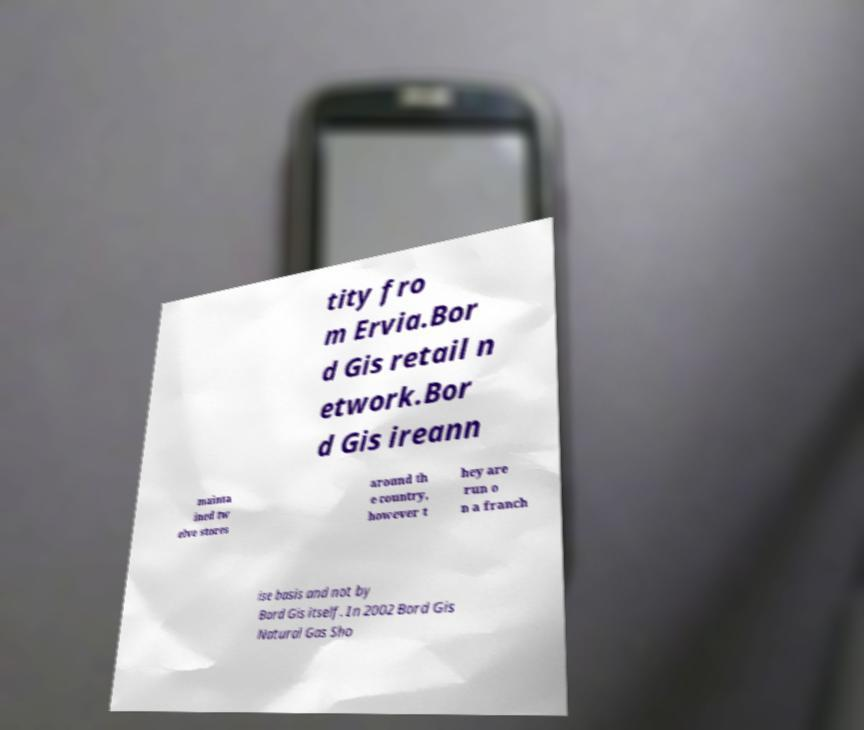For documentation purposes, I need the text within this image transcribed. Could you provide that? tity fro m Ervia.Bor d Gis retail n etwork.Bor d Gis ireann mainta ined tw elve stores around th e country, however t hey are run o n a franch ise basis and not by Bord Gis itself. In 2002 Bord Gis Natural Gas Sho 